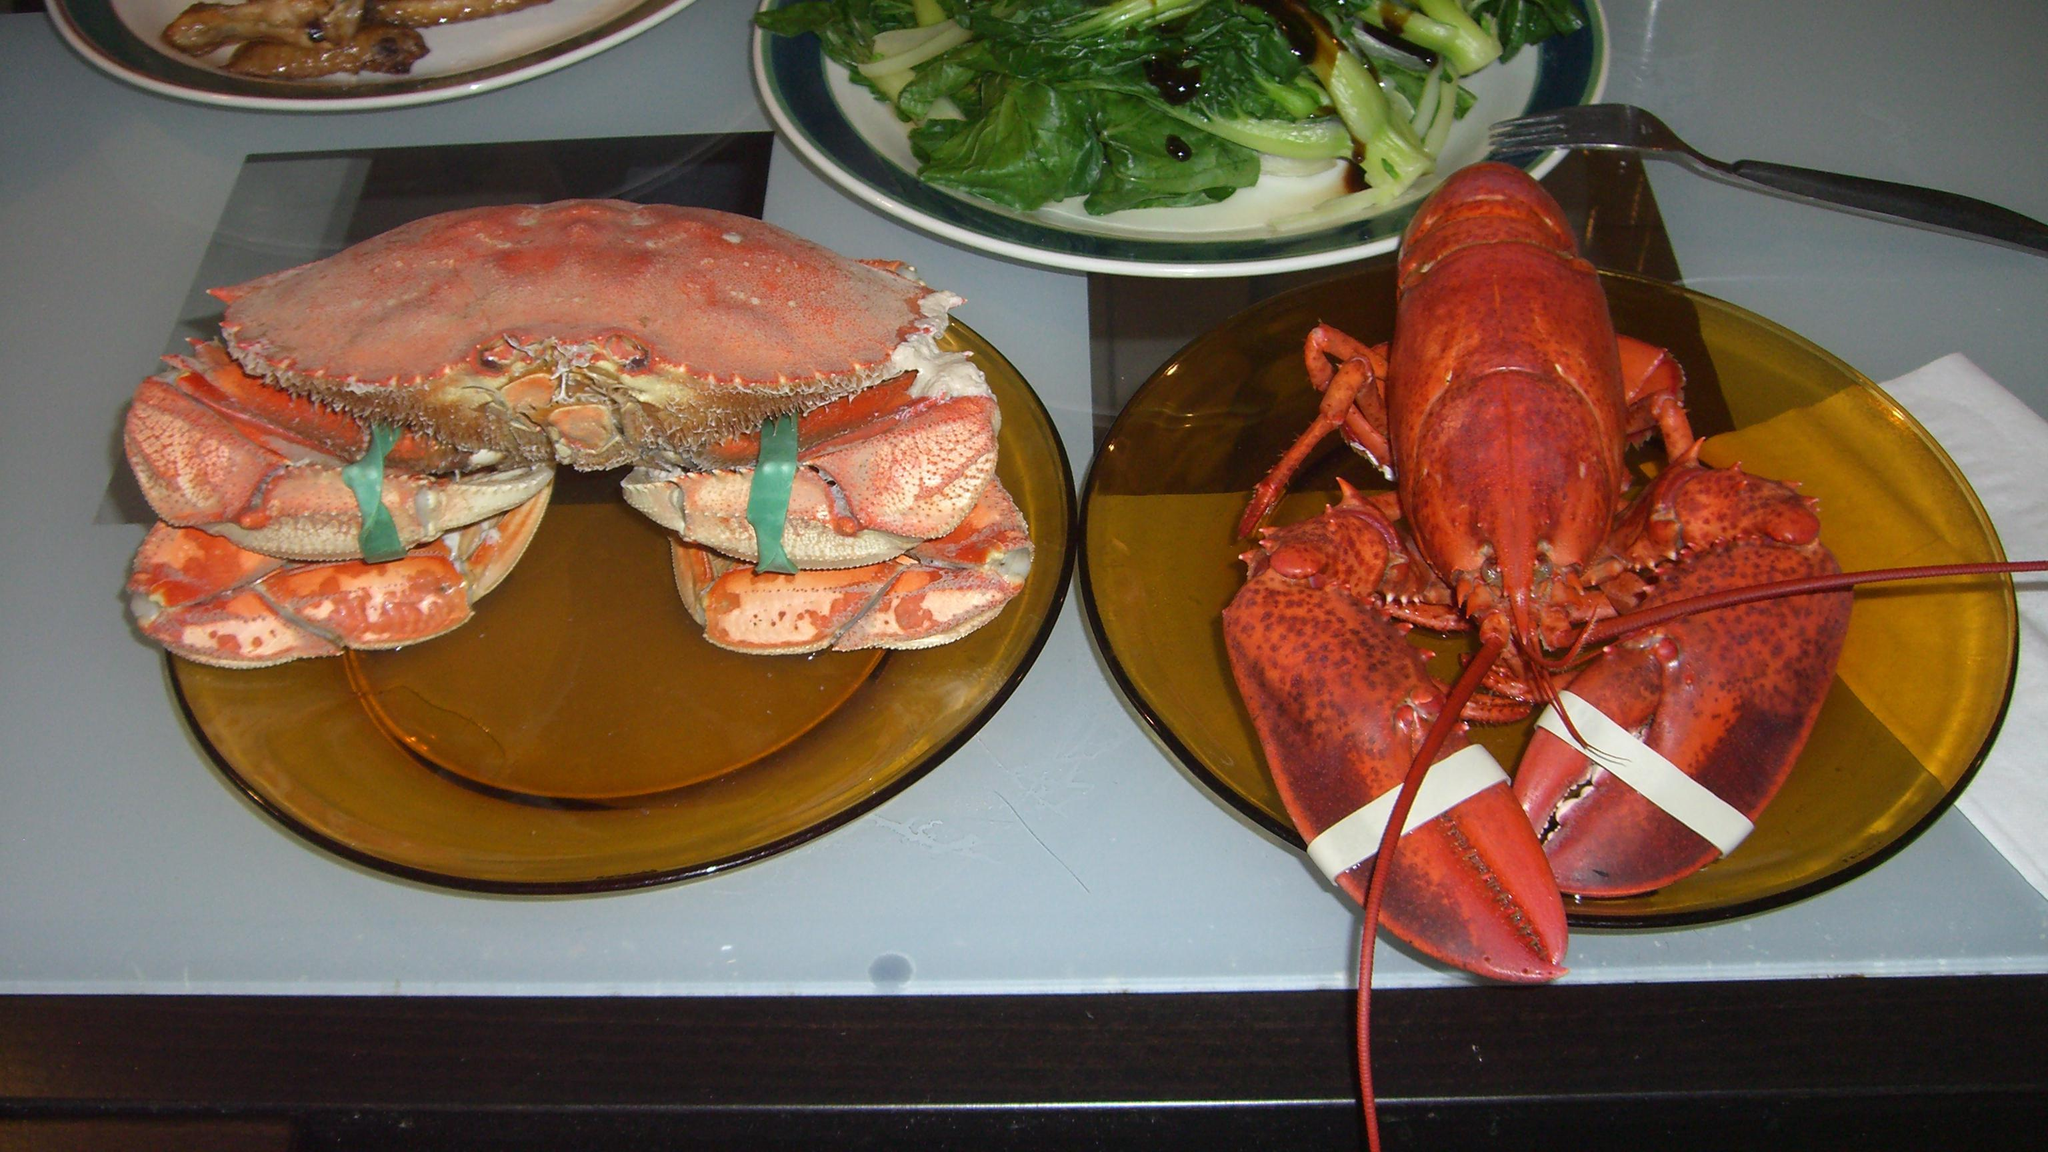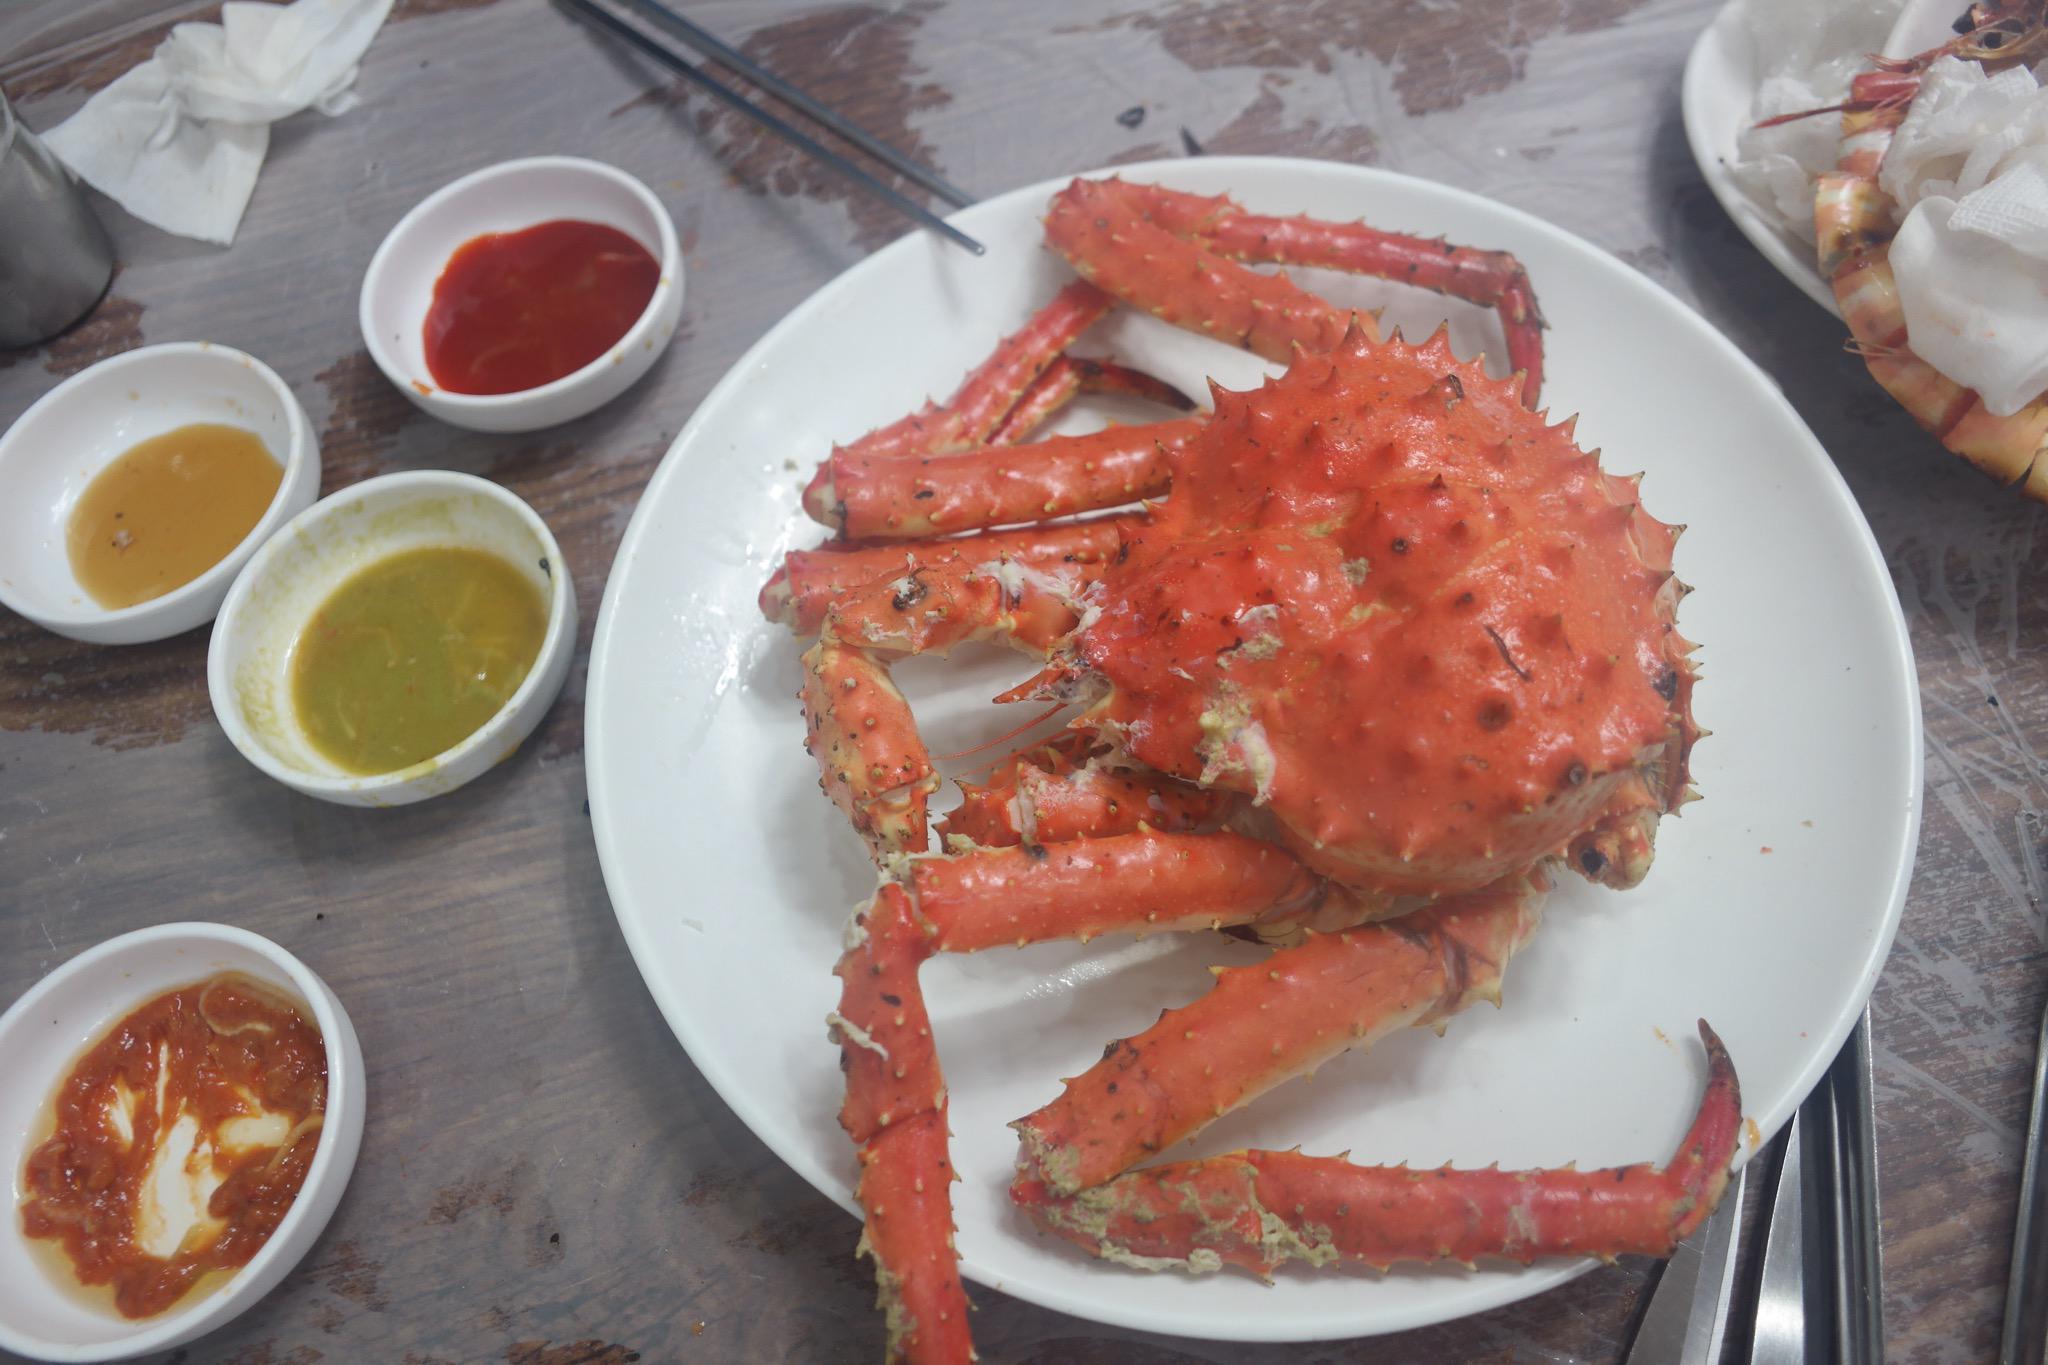The first image is the image on the left, the second image is the image on the right. Evaluate the accuracy of this statement regarding the images: "there is crab ready to serve with a wedge of lemon next to it". Is it true? Answer yes or no. No. The first image is the image on the left, the second image is the image on the right. Assess this claim about the two images: "In at least one image there is a single cooked crab upside down exposing it's soft parts.". Correct or not? Answer yes or no. No. 